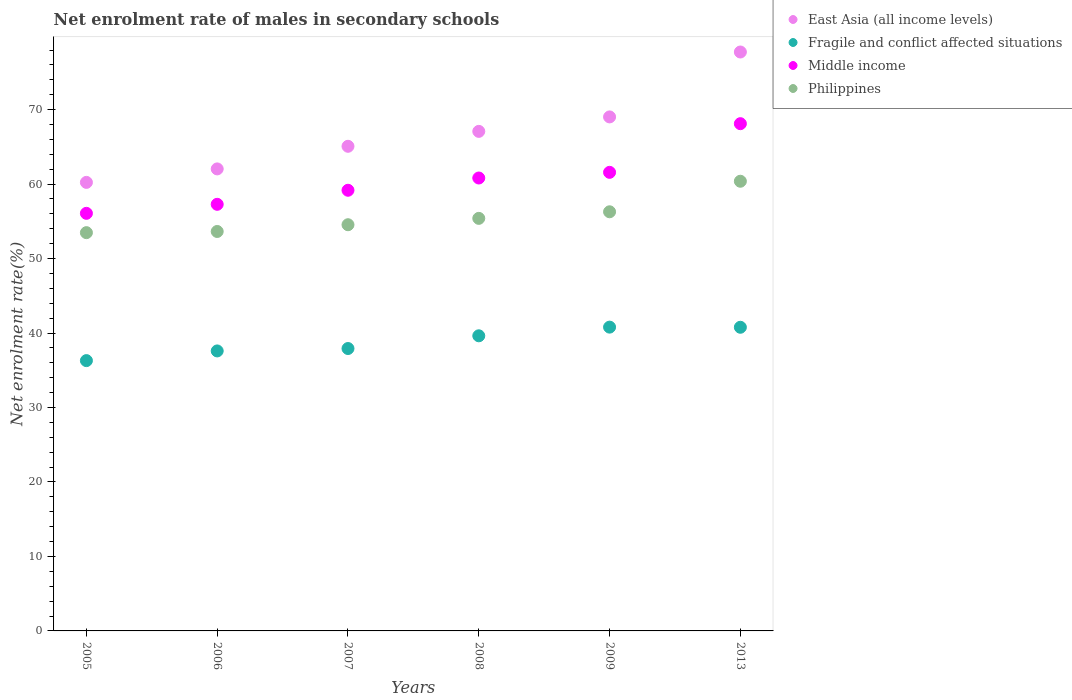How many different coloured dotlines are there?
Offer a terse response. 4. What is the net enrolment rate of males in secondary schools in Philippines in 2005?
Give a very brief answer. 53.48. Across all years, what is the maximum net enrolment rate of males in secondary schools in Fragile and conflict affected situations?
Your answer should be compact. 40.79. Across all years, what is the minimum net enrolment rate of males in secondary schools in East Asia (all income levels)?
Your answer should be compact. 60.23. In which year was the net enrolment rate of males in secondary schools in Middle income maximum?
Your answer should be compact. 2013. What is the total net enrolment rate of males in secondary schools in Philippines in the graph?
Make the answer very short. 333.72. What is the difference between the net enrolment rate of males in secondary schools in Fragile and conflict affected situations in 2006 and that in 2013?
Make the answer very short. -3.18. What is the difference between the net enrolment rate of males in secondary schools in Fragile and conflict affected situations in 2013 and the net enrolment rate of males in secondary schools in Philippines in 2007?
Give a very brief answer. -13.77. What is the average net enrolment rate of males in secondary schools in East Asia (all income levels) per year?
Provide a succinct answer. 66.86. In the year 2008, what is the difference between the net enrolment rate of males in secondary schools in Fragile and conflict affected situations and net enrolment rate of males in secondary schools in Philippines?
Make the answer very short. -15.77. What is the ratio of the net enrolment rate of males in secondary schools in Middle income in 2005 to that in 2008?
Offer a terse response. 0.92. Is the net enrolment rate of males in secondary schools in Fragile and conflict affected situations in 2006 less than that in 2008?
Ensure brevity in your answer.  Yes. Is the difference between the net enrolment rate of males in secondary schools in Fragile and conflict affected situations in 2008 and 2009 greater than the difference between the net enrolment rate of males in secondary schools in Philippines in 2008 and 2009?
Ensure brevity in your answer.  No. What is the difference between the highest and the second highest net enrolment rate of males in secondary schools in East Asia (all income levels)?
Provide a short and direct response. 8.72. What is the difference between the highest and the lowest net enrolment rate of males in secondary schools in Philippines?
Your answer should be compact. 6.9. In how many years, is the net enrolment rate of males in secondary schools in Fragile and conflict affected situations greater than the average net enrolment rate of males in secondary schools in Fragile and conflict affected situations taken over all years?
Offer a terse response. 3. Is it the case that in every year, the sum of the net enrolment rate of males in secondary schools in Middle income and net enrolment rate of males in secondary schools in Philippines  is greater than the sum of net enrolment rate of males in secondary schools in East Asia (all income levels) and net enrolment rate of males in secondary schools in Fragile and conflict affected situations?
Provide a succinct answer. No. Is it the case that in every year, the sum of the net enrolment rate of males in secondary schools in East Asia (all income levels) and net enrolment rate of males in secondary schools in Middle income  is greater than the net enrolment rate of males in secondary schools in Fragile and conflict affected situations?
Ensure brevity in your answer.  Yes. How many dotlines are there?
Your answer should be very brief. 4. What is the difference between two consecutive major ticks on the Y-axis?
Ensure brevity in your answer.  10. Does the graph contain any zero values?
Keep it short and to the point. No. Does the graph contain grids?
Keep it short and to the point. No. How many legend labels are there?
Your answer should be very brief. 4. How are the legend labels stacked?
Keep it short and to the point. Vertical. What is the title of the graph?
Your answer should be compact. Net enrolment rate of males in secondary schools. What is the label or title of the Y-axis?
Your answer should be compact. Net enrolment rate(%). What is the Net enrolment rate(%) of East Asia (all income levels) in 2005?
Your answer should be compact. 60.23. What is the Net enrolment rate(%) in Fragile and conflict affected situations in 2005?
Provide a short and direct response. 36.3. What is the Net enrolment rate(%) of Middle income in 2005?
Your answer should be compact. 56.07. What is the Net enrolment rate(%) in Philippines in 2005?
Your answer should be very brief. 53.48. What is the Net enrolment rate(%) of East Asia (all income levels) in 2006?
Offer a terse response. 62.04. What is the Net enrolment rate(%) of Fragile and conflict affected situations in 2006?
Make the answer very short. 37.6. What is the Net enrolment rate(%) of Middle income in 2006?
Make the answer very short. 57.28. What is the Net enrolment rate(%) in Philippines in 2006?
Your response must be concise. 53.64. What is the Net enrolment rate(%) of East Asia (all income levels) in 2007?
Your answer should be compact. 65.08. What is the Net enrolment rate(%) in Fragile and conflict affected situations in 2007?
Your answer should be compact. 37.92. What is the Net enrolment rate(%) of Middle income in 2007?
Make the answer very short. 59.17. What is the Net enrolment rate(%) in Philippines in 2007?
Make the answer very short. 54.54. What is the Net enrolment rate(%) in East Asia (all income levels) in 2008?
Provide a succinct answer. 67.08. What is the Net enrolment rate(%) of Fragile and conflict affected situations in 2008?
Your response must be concise. 39.63. What is the Net enrolment rate(%) of Middle income in 2008?
Offer a terse response. 60.82. What is the Net enrolment rate(%) of Philippines in 2008?
Offer a very short reply. 55.4. What is the Net enrolment rate(%) in East Asia (all income levels) in 2009?
Provide a succinct answer. 69.02. What is the Net enrolment rate(%) in Fragile and conflict affected situations in 2009?
Offer a very short reply. 40.79. What is the Net enrolment rate(%) of Middle income in 2009?
Give a very brief answer. 61.58. What is the Net enrolment rate(%) of Philippines in 2009?
Offer a very short reply. 56.28. What is the Net enrolment rate(%) in East Asia (all income levels) in 2013?
Make the answer very short. 77.74. What is the Net enrolment rate(%) in Fragile and conflict affected situations in 2013?
Your response must be concise. 40.77. What is the Net enrolment rate(%) of Middle income in 2013?
Your answer should be compact. 68.11. What is the Net enrolment rate(%) of Philippines in 2013?
Provide a short and direct response. 60.38. Across all years, what is the maximum Net enrolment rate(%) in East Asia (all income levels)?
Keep it short and to the point. 77.74. Across all years, what is the maximum Net enrolment rate(%) in Fragile and conflict affected situations?
Keep it short and to the point. 40.79. Across all years, what is the maximum Net enrolment rate(%) in Middle income?
Make the answer very short. 68.11. Across all years, what is the maximum Net enrolment rate(%) of Philippines?
Your answer should be very brief. 60.38. Across all years, what is the minimum Net enrolment rate(%) of East Asia (all income levels)?
Make the answer very short. 60.23. Across all years, what is the minimum Net enrolment rate(%) in Fragile and conflict affected situations?
Make the answer very short. 36.3. Across all years, what is the minimum Net enrolment rate(%) of Middle income?
Offer a very short reply. 56.07. Across all years, what is the minimum Net enrolment rate(%) in Philippines?
Offer a terse response. 53.48. What is the total Net enrolment rate(%) of East Asia (all income levels) in the graph?
Your answer should be very brief. 401.18. What is the total Net enrolment rate(%) of Fragile and conflict affected situations in the graph?
Offer a terse response. 233.01. What is the total Net enrolment rate(%) of Middle income in the graph?
Provide a succinct answer. 363.04. What is the total Net enrolment rate(%) in Philippines in the graph?
Provide a succinct answer. 333.72. What is the difference between the Net enrolment rate(%) of East Asia (all income levels) in 2005 and that in 2006?
Offer a terse response. -1.81. What is the difference between the Net enrolment rate(%) of Fragile and conflict affected situations in 2005 and that in 2006?
Your answer should be very brief. -1.3. What is the difference between the Net enrolment rate(%) of Middle income in 2005 and that in 2006?
Offer a terse response. -1.21. What is the difference between the Net enrolment rate(%) of Philippines in 2005 and that in 2006?
Give a very brief answer. -0.16. What is the difference between the Net enrolment rate(%) of East Asia (all income levels) in 2005 and that in 2007?
Make the answer very short. -4.85. What is the difference between the Net enrolment rate(%) in Fragile and conflict affected situations in 2005 and that in 2007?
Your answer should be compact. -1.62. What is the difference between the Net enrolment rate(%) of Middle income in 2005 and that in 2007?
Offer a very short reply. -3.1. What is the difference between the Net enrolment rate(%) in Philippines in 2005 and that in 2007?
Your response must be concise. -1.06. What is the difference between the Net enrolment rate(%) of East Asia (all income levels) in 2005 and that in 2008?
Provide a short and direct response. -6.85. What is the difference between the Net enrolment rate(%) of Fragile and conflict affected situations in 2005 and that in 2008?
Keep it short and to the point. -3.33. What is the difference between the Net enrolment rate(%) in Middle income in 2005 and that in 2008?
Your response must be concise. -4.74. What is the difference between the Net enrolment rate(%) of Philippines in 2005 and that in 2008?
Your answer should be compact. -1.92. What is the difference between the Net enrolment rate(%) in East Asia (all income levels) in 2005 and that in 2009?
Offer a very short reply. -8.79. What is the difference between the Net enrolment rate(%) in Fragile and conflict affected situations in 2005 and that in 2009?
Your answer should be compact. -4.5. What is the difference between the Net enrolment rate(%) of Middle income in 2005 and that in 2009?
Provide a succinct answer. -5.5. What is the difference between the Net enrolment rate(%) of Philippines in 2005 and that in 2009?
Provide a succinct answer. -2.8. What is the difference between the Net enrolment rate(%) of East Asia (all income levels) in 2005 and that in 2013?
Offer a very short reply. -17.51. What is the difference between the Net enrolment rate(%) of Fragile and conflict affected situations in 2005 and that in 2013?
Provide a short and direct response. -4.48. What is the difference between the Net enrolment rate(%) of Middle income in 2005 and that in 2013?
Your answer should be very brief. -12.04. What is the difference between the Net enrolment rate(%) of Philippines in 2005 and that in 2013?
Keep it short and to the point. -6.9. What is the difference between the Net enrolment rate(%) in East Asia (all income levels) in 2006 and that in 2007?
Provide a short and direct response. -3.04. What is the difference between the Net enrolment rate(%) of Fragile and conflict affected situations in 2006 and that in 2007?
Your answer should be very brief. -0.32. What is the difference between the Net enrolment rate(%) of Middle income in 2006 and that in 2007?
Give a very brief answer. -1.89. What is the difference between the Net enrolment rate(%) in Philippines in 2006 and that in 2007?
Offer a terse response. -0.91. What is the difference between the Net enrolment rate(%) of East Asia (all income levels) in 2006 and that in 2008?
Make the answer very short. -5.04. What is the difference between the Net enrolment rate(%) in Fragile and conflict affected situations in 2006 and that in 2008?
Your response must be concise. -2.03. What is the difference between the Net enrolment rate(%) of Middle income in 2006 and that in 2008?
Provide a short and direct response. -3.53. What is the difference between the Net enrolment rate(%) of Philippines in 2006 and that in 2008?
Offer a terse response. -1.76. What is the difference between the Net enrolment rate(%) in East Asia (all income levels) in 2006 and that in 2009?
Your answer should be compact. -6.98. What is the difference between the Net enrolment rate(%) of Fragile and conflict affected situations in 2006 and that in 2009?
Provide a succinct answer. -3.2. What is the difference between the Net enrolment rate(%) of Middle income in 2006 and that in 2009?
Give a very brief answer. -4.29. What is the difference between the Net enrolment rate(%) in Philippines in 2006 and that in 2009?
Provide a short and direct response. -2.64. What is the difference between the Net enrolment rate(%) in East Asia (all income levels) in 2006 and that in 2013?
Give a very brief answer. -15.7. What is the difference between the Net enrolment rate(%) of Fragile and conflict affected situations in 2006 and that in 2013?
Offer a very short reply. -3.18. What is the difference between the Net enrolment rate(%) in Middle income in 2006 and that in 2013?
Provide a short and direct response. -10.83. What is the difference between the Net enrolment rate(%) of Philippines in 2006 and that in 2013?
Give a very brief answer. -6.75. What is the difference between the Net enrolment rate(%) of East Asia (all income levels) in 2007 and that in 2008?
Your answer should be compact. -2. What is the difference between the Net enrolment rate(%) of Fragile and conflict affected situations in 2007 and that in 2008?
Your response must be concise. -1.71. What is the difference between the Net enrolment rate(%) in Middle income in 2007 and that in 2008?
Offer a terse response. -1.65. What is the difference between the Net enrolment rate(%) in Philippines in 2007 and that in 2008?
Provide a short and direct response. -0.85. What is the difference between the Net enrolment rate(%) in East Asia (all income levels) in 2007 and that in 2009?
Provide a short and direct response. -3.94. What is the difference between the Net enrolment rate(%) of Fragile and conflict affected situations in 2007 and that in 2009?
Your answer should be very brief. -2.87. What is the difference between the Net enrolment rate(%) of Middle income in 2007 and that in 2009?
Your answer should be very brief. -2.41. What is the difference between the Net enrolment rate(%) in Philippines in 2007 and that in 2009?
Your answer should be compact. -1.74. What is the difference between the Net enrolment rate(%) of East Asia (all income levels) in 2007 and that in 2013?
Offer a terse response. -12.66. What is the difference between the Net enrolment rate(%) in Fragile and conflict affected situations in 2007 and that in 2013?
Your response must be concise. -2.85. What is the difference between the Net enrolment rate(%) in Middle income in 2007 and that in 2013?
Offer a terse response. -8.94. What is the difference between the Net enrolment rate(%) in Philippines in 2007 and that in 2013?
Provide a succinct answer. -5.84. What is the difference between the Net enrolment rate(%) in East Asia (all income levels) in 2008 and that in 2009?
Your answer should be very brief. -1.94. What is the difference between the Net enrolment rate(%) of Fragile and conflict affected situations in 2008 and that in 2009?
Keep it short and to the point. -1.16. What is the difference between the Net enrolment rate(%) in Middle income in 2008 and that in 2009?
Offer a very short reply. -0.76. What is the difference between the Net enrolment rate(%) of Philippines in 2008 and that in 2009?
Make the answer very short. -0.88. What is the difference between the Net enrolment rate(%) of East Asia (all income levels) in 2008 and that in 2013?
Your response must be concise. -10.66. What is the difference between the Net enrolment rate(%) of Fragile and conflict affected situations in 2008 and that in 2013?
Provide a succinct answer. -1.15. What is the difference between the Net enrolment rate(%) of Middle income in 2008 and that in 2013?
Offer a terse response. -7.29. What is the difference between the Net enrolment rate(%) of Philippines in 2008 and that in 2013?
Offer a terse response. -4.98. What is the difference between the Net enrolment rate(%) in East Asia (all income levels) in 2009 and that in 2013?
Your response must be concise. -8.72. What is the difference between the Net enrolment rate(%) in Fragile and conflict affected situations in 2009 and that in 2013?
Offer a very short reply. 0.02. What is the difference between the Net enrolment rate(%) in Middle income in 2009 and that in 2013?
Ensure brevity in your answer.  -6.53. What is the difference between the Net enrolment rate(%) of Philippines in 2009 and that in 2013?
Your answer should be very brief. -4.1. What is the difference between the Net enrolment rate(%) in East Asia (all income levels) in 2005 and the Net enrolment rate(%) in Fragile and conflict affected situations in 2006?
Make the answer very short. 22.63. What is the difference between the Net enrolment rate(%) of East Asia (all income levels) in 2005 and the Net enrolment rate(%) of Middle income in 2006?
Your answer should be compact. 2.94. What is the difference between the Net enrolment rate(%) of East Asia (all income levels) in 2005 and the Net enrolment rate(%) of Philippines in 2006?
Ensure brevity in your answer.  6.59. What is the difference between the Net enrolment rate(%) of Fragile and conflict affected situations in 2005 and the Net enrolment rate(%) of Middle income in 2006?
Provide a short and direct response. -20.99. What is the difference between the Net enrolment rate(%) in Fragile and conflict affected situations in 2005 and the Net enrolment rate(%) in Philippines in 2006?
Provide a succinct answer. -17.34. What is the difference between the Net enrolment rate(%) of Middle income in 2005 and the Net enrolment rate(%) of Philippines in 2006?
Your response must be concise. 2.44. What is the difference between the Net enrolment rate(%) in East Asia (all income levels) in 2005 and the Net enrolment rate(%) in Fragile and conflict affected situations in 2007?
Your answer should be compact. 22.31. What is the difference between the Net enrolment rate(%) in East Asia (all income levels) in 2005 and the Net enrolment rate(%) in Middle income in 2007?
Your answer should be very brief. 1.06. What is the difference between the Net enrolment rate(%) of East Asia (all income levels) in 2005 and the Net enrolment rate(%) of Philippines in 2007?
Give a very brief answer. 5.69. What is the difference between the Net enrolment rate(%) in Fragile and conflict affected situations in 2005 and the Net enrolment rate(%) in Middle income in 2007?
Offer a very short reply. -22.88. What is the difference between the Net enrolment rate(%) in Fragile and conflict affected situations in 2005 and the Net enrolment rate(%) in Philippines in 2007?
Your response must be concise. -18.25. What is the difference between the Net enrolment rate(%) in Middle income in 2005 and the Net enrolment rate(%) in Philippines in 2007?
Provide a short and direct response. 1.53. What is the difference between the Net enrolment rate(%) of East Asia (all income levels) in 2005 and the Net enrolment rate(%) of Fragile and conflict affected situations in 2008?
Make the answer very short. 20.6. What is the difference between the Net enrolment rate(%) of East Asia (all income levels) in 2005 and the Net enrolment rate(%) of Middle income in 2008?
Your answer should be very brief. -0.59. What is the difference between the Net enrolment rate(%) in East Asia (all income levels) in 2005 and the Net enrolment rate(%) in Philippines in 2008?
Offer a very short reply. 4.83. What is the difference between the Net enrolment rate(%) of Fragile and conflict affected situations in 2005 and the Net enrolment rate(%) of Middle income in 2008?
Your response must be concise. -24.52. What is the difference between the Net enrolment rate(%) in Fragile and conflict affected situations in 2005 and the Net enrolment rate(%) in Philippines in 2008?
Give a very brief answer. -19.1. What is the difference between the Net enrolment rate(%) of Middle income in 2005 and the Net enrolment rate(%) of Philippines in 2008?
Give a very brief answer. 0.68. What is the difference between the Net enrolment rate(%) in East Asia (all income levels) in 2005 and the Net enrolment rate(%) in Fragile and conflict affected situations in 2009?
Your answer should be very brief. 19.44. What is the difference between the Net enrolment rate(%) of East Asia (all income levels) in 2005 and the Net enrolment rate(%) of Middle income in 2009?
Give a very brief answer. -1.35. What is the difference between the Net enrolment rate(%) of East Asia (all income levels) in 2005 and the Net enrolment rate(%) of Philippines in 2009?
Make the answer very short. 3.95. What is the difference between the Net enrolment rate(%) in Fragile and conflict affected situations in 2005 and the Net enrolment rate(%) in Middle income in 2009?
Ensure brevity in your answer.  -25.28. What is the difference between the Net enrolment rate(%) in Fragile and conflict affected situations in 2005 and the Net enrolment rate(%) in Philippines in 2009?
Give a very brief answer. -19.99. What is the difference between the Net enrolment rate(%) in Middle income in 2005 and the Net enrolment rate(%) in Philippines in 2009?
Keep it short and to the point. -0.21. What is the difference between the Net enrolment rate(%) of East Asia (all income levels) in 2005 and the Net enrolment rate(%) of Fragile and conflict affected situations in 2013?
Give a very brief answer. 19.46. What is the difference between the Net enrolment rate(%) in East Asia (all income levels) in 2005 and the Net enrolment rate(%) in Middle income in 2013?
Give a very brief answer. -7.88. What is the difference between the Net enrolment rate(%) in East Asia (all income levels) in 2005 and the Net enrolment rate(%) in Philippines in 2013?
Make the answer very short. -0.15. What is the difference between the Net enrolment rate(%) of Fragile and conflict affected situations in 2005 and the Net enrolment rate(%) of Middle income in 2013?
Make the answer very short. -31.82. What is the difference between the Net enrolment rate(%) of Fragile and conflict affected situations in 2005 and the Net enrolment rate(%) of Philippines in 2013?
Your answer should be very brief. -24.09. What is the difference between the Net enrolment rate(%) of Middle income in 2005 and the Net enrolment rate(%) of Philippines in 2013?
Offer a very short reply. -4.31. What is the difference between the Net enrolment rate(%) of East Asia (all income levels) in 2006 and the Net enrolment rate(%) of Fragile and conflict affected situations in 2007?
Provide a succinct answer. 24.12. What is the difference between the Net enrolment rate(%) in East Asia (all income levels) in 2006 and the Net enrolment rate(%) in Middle income in 2007?
Your answer should be compact. 2.87. What is the difference between the Net enrolment rate(%) in East Asia (all income levels) in 2006 and the Net enrolment rate(%) in Philippines in 2007?
Your response must be concise. 7.5. What is the difference between the Net enrolment rate(%) of Fragile and conflict affected situations in 2006 and the Net enrolment rate(%) of Middle income in 2007?
Give a very brief answer. -21.57. What is the difference between the Net enrolment rate(%) in Fragile and conflict affected situations in 2006 and the Net enrolment rate(%) in Philippines in 2007?
Provide a short and direct response. -16.95. What is the difference between the Net enrolment rate(%) in Middle income in 2006 and the Net enrolment rate(%) in Philippines in 2007?
Offer a very short reply. 2.74. What is the difference between the Net enrolment rate(%) of East Asia (all income levels) in 2006 and the Net enrolment rate(%) of Fragile and conflict affected situations in 2008?
Your answer should be compact. 22.41. What is the difference between the Net enrolment rate(%) of East Asia (all income levels) in 2006 and the Net enrolment rate(%) of Middle income in 2008?
Offer a terse response. 1.22. What is the difference between the Net enrolment rate(%) in East Asia (all income levels) in 2006 and the Net enrolment rate(%) in Philippines in 2008?
Give a very brief answer. 6.64. What is the difference between the Net enrolment rate(%) in Fragile and conflict affected situations in 2006 and the Net enrolment rate(%) in Middle income in 2008?
Provide a short and direct response. -23.22. What is the difference between the Net enrolment rate(%) in Fragile and conflict affected situations in 2006 and the Net enrolment rate(%) in Philippines in 2008?
Keep it short and to the point. -17.8. What is the difference between the Net enrolment rate(%) in Middle income in 2006 and the Net enrolment rate(%) in Philippines in 2008?
Keep it short and to the point. 1.89. What is the difference between the Net enrolment rate(%) of East Asia (all income levels) in 2006 and the Net enrolment rate(%) of Fragile and conflict affected situations in 2009?
Give a very brief answer. 21.25. What is the difference between the Net enrolment rate(%) in East Asia (all income levels) in 2006 and the Net enrolment rate(%) in Middle income in 2009?
Offer a very short reply. 0.46. What is the difference between the Net enrolment rate(%) of East Asia (all income levels) in 2006 and the Net enrolment rate(%) of Philippines in 2009?
Provide a succinct answer. 5.76. What is the difference between the Net enrolment rate(%) in Fragile and conflict affected situations in 2006 and the Net enrolment rate(%) in Middle income in 2009?
Keep it short and to the point. -23.98. What is the difference between the Net enrolment rate(%) in Fragile and conflict affected situations in 2006 and the Net enrolment rate(%) in Philippines in 2009?
Provide a succinct answer. -18.68. What is the difference between the Net enrolment rate(%) of East Asia (all income levels) in 2006 and the Net enrolment rate(%) of Fragile and conflict affected situations in 2013?
Keep it short and to the point. 21.26. What is the difference between the Net enrolment rate(%) of East Asia (all income levels) in 2006 and the Net enrolment rate(%) of Middle income in 2013?
Ensure brevity in your answer.  -6.07. What is the difference between the Net enrolment rate(%) of East Asia (all income levels) in 2006 and the Net enrolment rate(%) of Philippines in 2013?
Your response must be concise. 1.66. What is the difference between the Net enrolment rate(%) in Fragile and conflict affected situations in 2006 and the Net enrolment rate(%) in Middle income in 2013?
Your response must be concise. -30.52. What is the difference between the Net enrolment rate(%) in Fragile and conflict affected situations in 2006 and the Net enrolment rate(%) in Philippines in 2013?
Your answer should be very brief. -22.79. What is the difference between the Net enrolment rate(%) in Middle income in 2006 and the Net enrolment rate(%) in Philippines in 2013?
Offer a terse response. -3.1. What is the difference between the Net enrolment rate(%) of East Asia (all income levels) in 2007 and the Net enrolment rate(%) of Fragile and conflict affected situations in 2008?
Keep it short and to the point. 25.45. What is the difference between the Net enrolment rate(%) in East Asia (all income levels) in 2007 and the Net enrolment rate(%) in Middle income in 2008?
Your answer should be very brief. 4.26. What is the difference between the Net enrolment rate(%) of East Asia (all income levels) in 2007 and the Net enrolment rate(%) of Philippines in 2008?
Offer a terse response. 9.68. What is the difference between the Net enrolment rate(%) of Fragile and conflict affected situations in 2007 and the Net enrolment rate(%) of Middle income in 2008?
Keep it short and to the point. -22.9. What is the difference between the Net enrolment rate(%) in Fragile and conflict affected situations in 2007 and the Net enrolment rate(%) in Philippines in 2008?
Provide a succinct answer. -17.48. What is the difference between the Net enrolment rate(%) in Middle income in 2007 and the Net enrolment rate(%) in Philippines in 2008?
Give a very brief answer. 3.77. What is the difference between the Net enrolment rate(%) in East Asia (all income levels) in 2007 and the Net enrolment rate(%) in Fragile and conflict affected situations in 2009?
Your answer should be very brief. 24.28. What is the difference between the Net enrolment rate(%) of East Asia (all income levels) in 2007 and the Net enrolment rate(%) of Middle income in 2009?
Give a very brief answer. 3.5. What is the difference between the Net enrolment rate(%) in East Asia (all income levels) in 2007 and the Net enrolment rate(%) in Philippines in 2009?
Your response must be concise. 8.79. What is the difference between the Net enrolment rate(%) of Fragile and conflict affected situations in 2007 and the Net enrolment rate(%) of Middle income in 2009?
Your answer should be very brief. -23.66. What is the difference between the Net enrolment rate(%) of Fragile and conflict affected situations in 2007 and the Net enrolment rate(%) of Philippines in 2009?
Provide a succinct answer. -18.36. What is the difference between the Net enrolment rate(%) in Middle income in 2007 and the Net enrolment rate(%) in Philippines in 2009?
Keep it short and to the point. 2.89. What is the difference between the Net enrolment rate(%) in East Asia (all income levels) in 2007 and the Net enrolment rate(%) in Fragile and conflict affected situations in 2013?
Ensure brevity in your answer.  24.3. What is the difference between the Net enrolment rate(%) in East Asia (all income levels) in 2007 and the Net enrolment rate(%) in Middle income in 2013?
Provide a short and direct response. -3.04. What is the difference between the Net enrolment rate(%) in East Asia (all income levels) in 2007 and the Net enrolment rate(%) in Philippines in 2013?
Ensure brevity in your answer.  4.69. What is the difference between the Net enrolment rate(%) in Fragile and conflict affected situations in 2007 and the Net enrolment rate(%) in Middle income in 2013?
Keep it short and to the point. -30.19. What is the difference between the Net enrolment rate(%) of Fragile and conflict affected situations in 2007 and the Net enrolment rate(%) of Philippines in 2013?
Offer a terse response. -22.46. What is the difference between the Net enrolment rate(%) in Middle income in 2007 and the Net enrolment rate(%) in Philippines in 2013?
Offer a very short reply. -1.21. What is the difference between the Net enrolment rate(%) in East Asia (all income levels) in 2008 and the Net enrolment rate(%) in Fragile and conflict affected situations in 2009?
Keep it short and to the point. 26.29. What is the difference between the Net enrolment rate(%) of East Asia (all income levels) in 2008 and the Net enrolment rate(%) of Middle income in 2009?
Make the answer very short. 5.5. What is the difference between the Net enrolment rate(%) of East Asia (all income levels) in 2008 and the Net enrolment rate(%) of Philippines in 2009?
Offer a very short reply. 10.8. What is the difference between the Net enrolment rate(%) of Fragile and conflict affected situations in 2008 and the Net enrolment rate(%) of Middle income in 2009?
Provide a short and direct response. -21.95. What is the difference between the Net enrolment rate(%) of Fragile and conflict affected situations in 2008 and the Net enrolment rate(%) of Philippines in 2009?
Your answer should be very brief. -16.65. What is the difference between the Net enrolment rate(%) in Middle income in 2008 and the Net enrolment rate(%) in Philippines in 2009?
Keep it short and to the point. 4.54. What is the difference between the Net enrolment rate(%) in East Asia (all income levels) in 2008 and the Net enrolment rate(%) in Fragile and conflict affected situations in 2013?
Make the answer very short. 26.3. What is the difference between the Net enrolment rate(%) of East Asia (all income levels) in 2008 and the Net enrolment rate(%) of Middle income in 2013?
Give a very brief answer. -1.03. What is the difference between the Net enrolment rate(%) in East Asia (all income levels) in 2008 and the Net enrolment rate(%) in Philippines in 2013?
Give a very brief answer. 6.7. What is the difference between the Net enrolment rate(%) of Fragile and conflict affected situations in 2008 and the Net enrolment rate(%) of Middle income in 2013?
Your answer should be very brief. -28.48. What is the difference between the Net enrolment rate(%) in Fragile and conflict affected situations in 2008 and the Net enrolment rate(%) in Philippines in 2013?
Offer a terse response. -20.75. What is the difference between the Net enrolment rate(%) in Middle income in 2008 and the Net enrolment rate(%) in Philippines in 2013?
Your response must be concise. 0.44. What is the difference between the Net enrolment rate(%) in East Asia (all income levels) in 2009 and the Net enrolment rate(%) in Fragile and conflict affected situations in 2013?
Make the answer very short. 28.25. What is the difference between the Net enrolment rate(%) of East Asia (all income levels) in 2009 and the Net enrolment rate(%) of Middle income in 2013?
Offer a very short reply. 0.91. What is the difference between the Net enrolment rate(%) of East Asia (all income levels) in 2009 and the Net enrolment rate(%) of Philippines in 2013?
Your response must be concise. 8.64. What is the difference between the Net enrolment rate(%) of Fragile and conflict affected situations in 2009 and the Net enrolment rate(%) of Middle income in 2013?
Your answer should be compact. -27.32. What is the difference between the Net enrolment rate(%) in Fragile and conflict affected situations in 2009 and the Net enrolment rate(%) in Philippines in 2013?
Offer a terse response. -19.59. What is the difference between the Net enrolment rate(%) in Middle income in 2009 and the Net enrolment rate(%) in Philippines in 2013?
Keep it short and to the point. 1.2. What is the average Net enrolment rate(%) of East Asia (all income levels) per year?
Your answer should be very brief. 66.86. What is the average Net enrolment rate(%) in Fragile and conflict affected situations per year?
Your answer should be compact. 38.84. What is the average Net enrolment rate(%) of Middle income per year?
Provide a short and direct response. 60.51. What is the average Net enrolment rate(%) in Philippines per year?
Your answer should be compact. 55.62. In the year 2005, what is the difference between the Net enrolment rate(%) in East Asia (all income levels) and Net enrolment rate(%) in Fragile and conflict affected situations?
Your answer should be compact. 23.93. In the year 2005, what is the difference between the Net enrolment rate(%) of East Asia (all income levels) and Net enrolment rate(%) of Middle income?
Offer a terse response. 4.16. In the year 2005, what is the difference between the Net enrolment rate(%) in East Asia (all income levels) and Net enrolment rate(%) in Philippines?
Offer a very short reply. 6.75. In the year 2005, what is the difference between the Net enrolment rate(%) in Fragile and conflict affected situations and Net enrolment rate(%) in Middle income?
Provide a short and direct response. -19.78. In the year 2005, what is the difference between the Net enrolment rate(%) of Fragile and conflict affected situations and Net enrolment rate(%) of Philippines?
Give a very brief answer. -17.18. In the year 2005, what is the difference between the Net enrolment rate(%) in Middle income and Net enrolment rate(%) in Philippines?
Your answer should be very brief. 2.6. In the year 2006, what is the difference between the Net enrolment rate(%) in East Asia (all income levels) and Net enrolment rate(%) in Fragile and conflict affected situations?
Your answer should be compact. 24.44. In the year 2006, what is the difference between the Net enrolment rate(%) in East Asia (all income levels) and Net enrolment rate(%) in Middle income?
Provide a succinct answer. 4.75. In the year 2006, what is the difference between the Net enrolment rate(%) of East Asia (all income levels) and Net enrolment rate(%) of Philippines?
Provide a short and direct response. 8.4. In the year 2006, what is the difference between the Net enrolment rate(%) of Fragile and conflict affected situations and Net enrolment rate(%) of Middle income?
Ensure brevity in your answer.  -19.69. In the year 2006, what is the difference between the Net enrolment rate(%) in Fragile and conflict affected situations and Net enrolment rate(%) in Philippines?
Offer a terse response. -16.04. In the year 2006, what is the difference between the Net enrolment rate(%) of Middle income and Net enrolment rate(%) of Philippines?
Provide a succinct answer. 3.65. In the year 2007, what is the difference between the Net enrolment rate(%) of East Asia (all income levels) and Net enrolment rate(%) of Fragile and conflict affected situations?
Give a very brief answer. 27.16. In the year 2007, what is the difference between the Net enrolment rate(%) in East Asia (all income levels) and Net enrolment rate(%) in Middle income?
Offer a terse response. 5.91. In the year 2007, what is the difference between the Net enrolment rate(%) in East Asia (all income levels) and Net enrolment rate(%) in Philippines?
Your answer should be very brief. 10.53. In the year 2007, what is the difference between the Net enrolment rate(%) of Fragile and conflict affected situations and Net enrolment rate(%) of Middle income?
Your response must be concise. -21.25. In the year 2007, what is the difference between the Net enrolment rate(%) in Fragile and conflict affected situations and Net enrolment rate(%) in Philippines?
Offer a very short reply. -16.62. In the year 2007, what is the difference between the Net enrolment rate(%) in Middle income and Net enrolment rate(%) in Philippines?
Your answer should be very brief. 4.63. In the year 2008, what is the difference between the Net enrolment rate(%) of East Asia (all income levels) and Net enrolment rate(%) of Fragile and conflict affected situations?
Offer a very short reply. 27.45. In the year 2008, what is the difference between the Net enrolment rate(%) of East Asia (all income levels) and Net enrolment rate(%) of Middle income?
Your response must be concise. 6.26. In the year 2008, what is the difference between the Net enrolment rate(%) in East Asia (all income levels) and Net enrolment rate(%) in Philippines?
Give a very brief answer. 11.68. In the year 2008, what is the difference between the Net enrolment rate(%) of Fragile and conflict affected situations and Net enrolment rate(%) of Middle income?
Give a very brief answer. -21.19. In the year 2008, what is the difference between the Net enrolment rate(%) in Fragile and conflict affected situations and Net enrolment rate(%) in Philippines?
Your answer should be compact. -15.77. In the year 2008, what is the difference between the Net enrolment rate(%) of Middle income and Net enrolment rate(%) of Philippines?
Make the answer very short. 5.42. In the year 2009, what is the difference between the Net enrolment rate(%) in East Asia (all income levels) and Net enrolment rate(%) in Fragile and conflict affected situations?
Give a very brief answer. 28.23. In the year 2009, what is the difference between the Net enrolment rate(%) in East Asia (all income levels) and Net enrolment rate(%) in Middle income?
Offer a very short reply. 7.44. In the year 2009, what is the difference between the Net enrolment rate(%) in East Asia (all income levels) and Net enrolment rate(%) in Philippines?
Offer a very short reply. 12.74. In the year 2009, what is the difference between the Net enrolment rate(%) of Fragile and conflict affected situations and Net enrolment rate(%) of Middle income?
Give a very brief answer. -20.79. In the year 2009, what is the difference between the Net enrolment rate(%) in Fragile and conflict affected situations and Net enrolment rate(%) in Philippines?
Make the answer very short. -15.49. In the year 2009, what is the difference between the Net enrolment rate(%) of Middle income and Net enrolment rate(%) of Philippines?
Provide a succinct answer. 5.3. In the year 2013, what is the difference between the Net enrolment rate(%) of East Asia (all income levels) and Net enrolment rate(%) of Fragile and conflict affected situations?
Offer a terse response. 36.96. In the year 2013, what is the difference between the Net enrolment rate(%) of East Asia (all income levels) and Net enrolment rate(%) of Middle income?
Your response must be concise. 9.62. In the year 2013, what is the difference between the Net enrolment rate(%) of East Asia (all income levels) and Net enrolment rate(%) of Philippines?
Offer a very short reply. 17.35. In the year 2013, what is the difference between the Net enrolment rate(%) of Fragile and conflict affected situations and Net enrolment rate(%) of Middle income?
Your response must be concise. -27.34. In the year 2013, what is the difference between the Net enrolment rate(%) of Fragile and conflict affected situations and Net enrolment rate(%) of Philippines?
Your response must be concise. -19.61. In the year 2013, what is the difference between the Net enrolment rate(%) in Middle income and Net enrolment rate(%) in Philippines?
Provide a succinct answer. 7.73. What is the ratio of the Net enrolment rate(%) in East Asia (all income levels) in 2005 to that in 2006?
Give a very brief answer. 0.97. What is the ratio of the Net enrolment rate(%) of Fragile and conflict affected situations in 2005 to that in 2006?
Provide a short and direct response. 0.97. What is the ratio of the Net enrolment rate(%) in Middle income in 2005 to that in 2006?
Offer a very short reply. 0.98. What is the ratio of the Net enrolment rate(%) in East Asia (all income levels) in 2005 to that in 2007?
Make the answer very short. 0.93. What is the ratio of the Net enrolment rate(%) in Fragile and conflict affected situations in 2005 to that in 2007?
Provide a short and direct response. 0.96. What is the ratio of the Net enrolment rate(%) in Middle income in 2005 to that in 2007?
Your response must be concise. 0.95. What is the ratio of the Net enrolment rate(%) in Philippines in 2005 to that in 2007?
Keep it short and to the point. 0.98. What is the ratio of the Net enrolment rate(%) in East Asia (all income levels) in 2005 to that in 2008?
Give a very brief answer. 0.9. What is the ratio of the Net enrolment rate(%) of Fragile and conflict affected situations in 2005 to that in 2008?
Offer a very short reply. 0.92. What is the ratio of the Net enrolment rate(%) in Middle income in 2005 to that in 2008?
Your response must be concise. 0.92. What is the ratio of the Net enrolment rate(%) of Philippines in 2005 to that in 2008?
Offer a terse response. 0.97. What is the ratio of the Net enrolment rate(%) in East Asia (all income levels) in 2005 to that in 2009?
Provide a succinct answer. 0.87. What is the ratio of the Net enrolment rate(%) in Fragile and conflict affected situations in 2005 to that in 2009?
Make the answer very short. 0.89. What is the ratio of the Net enrolment rate(%) in Middle income in 2005 to that in 2009?
Keep it short and to the point. 0.91. What is the ratio of the Net enrolment rate(%) in Philippines in 2005 to that in 2009?
Provide a short and direct response. 0.95. What is the ratio of the Net enrolment rate(%) of East Asia (all income levels) in 2005 to that in 2013?
Keep it short and to the point. 0.77. What is the ratio of the Net enrolment rate(%) in Fragile and conflict affected situations in 2005 to that in 2013?
Your answer should be very brief. 0.89. What is the ratio of the Net enrolment rate(%) of Middle income in 2005 to that in 2013?
Provide a succinct answer. 0.82. What is the ratio of the Net enrolment rate(%) in Philippines in 2005 to that in 2013?
Provide a short and direct response. 0.89. What is the ratio of the Net enrolment rate(%) in East Asia (all income levels) in 2006 to that in 2007?
Give a very brief answer. 0.95. What is the ratio of the Net enrolment rate(%) of Middle income in 2006 to that in 2007?
Provide a succinct answer. 0.97. What is the ratio of the Net enrolment rate(%) in Philippines in 2006 to that in 2007?
Your response must be concise. 0.98. What is the ratio of the Net enrolment rate(%) in East Asia (all income levels) in 2006 to that in 2008?
Ensure brevity in your answer.  0.92. What is the ratio of the Net enrolment rate(%) in Fragile and conflict affected situations in 2006 to that in 2008?
Your answer should be very brief. 0.95. What is the ratio of the Net enrolment rate(%) of Middle income in 2006 to that in 2008?
Your response must be concise. 0.94. What is the ratio of the Net enrolment rate(%) of Philippines in 2006 to that in 2008?
Ensure brevity in your answer.  0.97. What is the ratio of the Net enrolment rate(%) of East Asia (all income levels) in 2006 to that in 2009?
Provide a succinct answer. 0.9. What is the ratio of the Net enrolment rate(%) of Fragile and conflict affected situations in 2006 to that in 2009?
Keep it short and to the point. 0.92. What is the ratio of the Net enrolment rate(%) of Middle income in 2006 to that in 2009?
Keep it short and to the point. 0.93. What is the ratio of the Net enrolment rate(%) in Philippines in 2006 to that in 2009?
Offer a terse response. 0.95. What is the ratio of the Net enrolment rate(%) in East Asia (all income levels) in 2006 to that in 2013?
Provide a short and direct response. 0.8. What is the ratio of the Net enrolment rate(%) in Fragile and conflict affected situations in 2006 to that in 2013?
Your response must be concise. 0.92. What is the ratio of the Net enrolment rate(%) in Middle income in 2006 to that in 2013?
Provide a succinct answer. 0.84. What is the ratio of the Net enrolment rate(%) in Philippines in 2006 to that in 2013?
Offer a terse response. 0.89. What is the ratio of the Net enrolment rate(%) in East Asia (all income levels) in 2007 to that in 2008?
Your answer should be compact. 0.97. What is the ratio of the Net enrolment rate(%) of Fragile and conflict affected situations in 2007 to that in 2008?
Offer a terse response. 0.96. What is the ratio of the Net enrolment rate(%) in Middle income in 2007 to that in 2008?
Provide a succinct answer. 0.97. What is the ratio of the Net enrolment rate(%) of Philippines in 2007 to that in 2008?
Give a very brief answer. 0.98. What is the ratio of the Net enrolment rate(%) in East Asia (all income levels) in 2007 to that in 2009?
Your response must be concise. 0.94. What is the ratio of the Net enrolment rate(%) of Fragile and conflict affected situations in 2007 to that in 2009?
Offer a terse response. 0.93. What is the ratio of the Net enrolment rate(%) of Middle income in 2007 to that in 2009?
Keep it short and to the point. 0.96. What is the ratio of the Net enrolment rate(%) of Philippines in 2007 to that in 2009?
Keep it short and to the point. 0.97. What is the ratio of the Net enrolment rate(%) in East Asia (all income levels) in 2007 to that in 2013?
Provide a short and direct response. 0.84. What is the ratio of the Net enrolment rate(%) of Fragile and conflict affected situations in 2007 to that in 2013?
Give a very brief answer. 0.93. What is the ratio of the Net enrolment rate(%) of Middle income in 2007 to that in 2013?
Provide a short and direct response. 0.87. What is the ratio of the Net enrolment rate(%) in Philippines in 2007 to that in 2013?
Provide a short and direct response. 0.9. What is the ratio of the Net enrolment rate(%) in East Asia (all income levels) in 2008 to that in 2009?
Your answer should be compact. 0.97. What is the ratio of the Net enrolment rate(%) of Fragile and conflict affected situations in 2008 to that in 2009?
Your answer should be compact. 0.97. What is the ratio of the Net enrolment rate(%) in Middle income in 2008 to that in 2009?
Keep it short and to the point. 0.99. What is the ratio of the Net enrolment rate(%) of Philippines in 2008 to that in 2009?
Keep it short and to the point. 0.98. What is the ratio of the Net enrolment rate(%) in East Asia (all income levels) in 2008 to that in 2013?
Provide a short and direct response. 0.86. What is the ratio of the Net enrolment rate(%) of Fragile and conflict affected situations in 2008 to that in 2013?
Make the answer very short. 0.97. What is the ratio of the Net enrolment rate(%) of Middle income in 2008 to that in 2013?
Your answer should be very brief. 0.89. What is the ratio of the Net enrolment rate(%) in Philippines in 2008 to that in 2013?
Ensure brevity in your answer.  0.92. What is the ratio of the Net enrolment rate(%) of East Asia (all income levels) in 2009 to that in 2013?
Your answer should be very brief. 0.89. What is the ratio of the Net enrolment rate(%) of Fragile and conflict affected situations in 2009 to that in 2013?
Ensure brevity in your answer.  1. What is the ratio of the Net enrolment rate(%) in Middle income in 2009 to that in 2013?
Your response must be concise. 0.9. What is the ratio of the Net enrolment rate(%) in Philippines in 2009 to that in 2013?
Provide a short and direct response. 0.93. What is the difference between the highest and the second highest Net enrolment rate(%) in East Asia (all income levels)?
Give a very brief answer. 8.72. What is the difference between the highest and the second highest Net enrolment rate(%) of Fragile and conflict affected situations?
Your answer should be compact. 0.02. What is the difference between the highest and the second highest Net enrolment rate(%) in Middle income?
Give a very brief answer. 6.53. What is the difference between the highest and the second highest Net enrolment rate(%) in Philippines?
Provide a succinct answer. 4.1. What is the difference between the highest and the lowest Net enrolment rate(%) in East Asia (all income levels)?
Your answer should be compact. 17.51. What is the difference between the highest and the lowest Net enrolment rate(%) in Fragile and conflict affected situations?
Provide a succinct answer. 4.5. What is the difference between the highest and the lowest Net enrolment rate(%) of Middle income?
Provide a succinct answer. 12.04. What is the difference between the highest and the lowest Net enrolment rate(%) of Philippines?
Give a very brief answer. 6.9. 